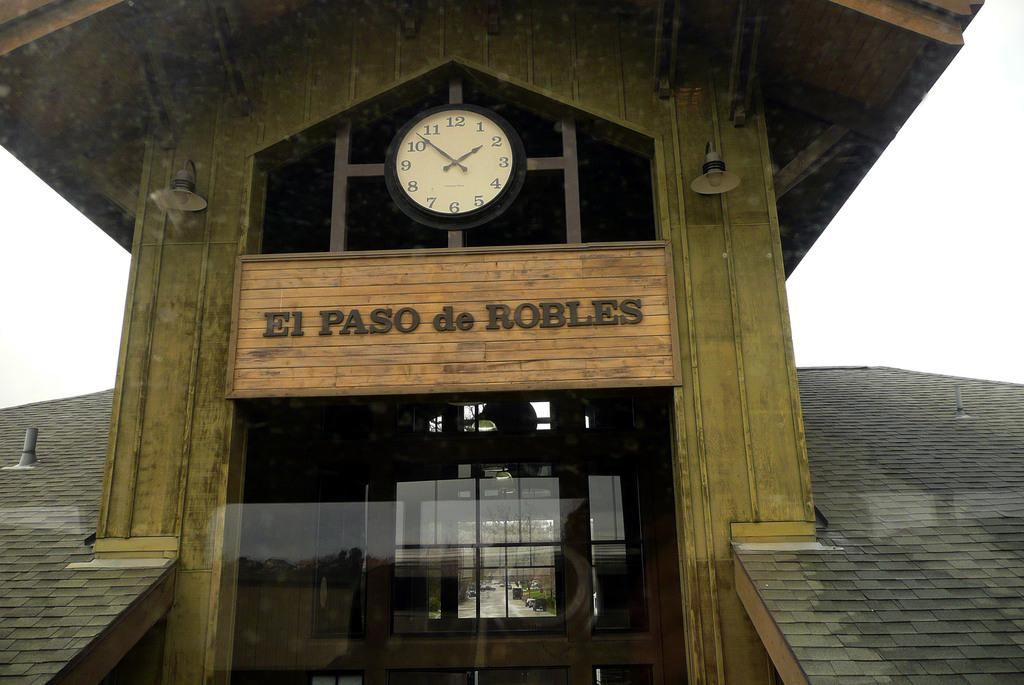<image>
Summarize the visual content of the image. front of building with el paso de robles above the entrance and a clock at 1:50 